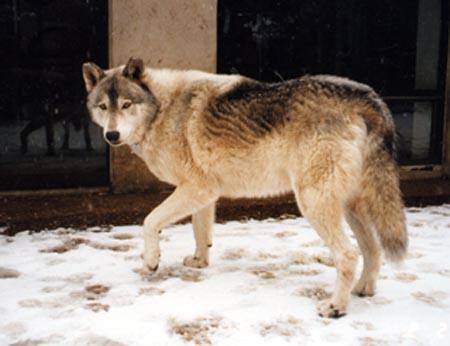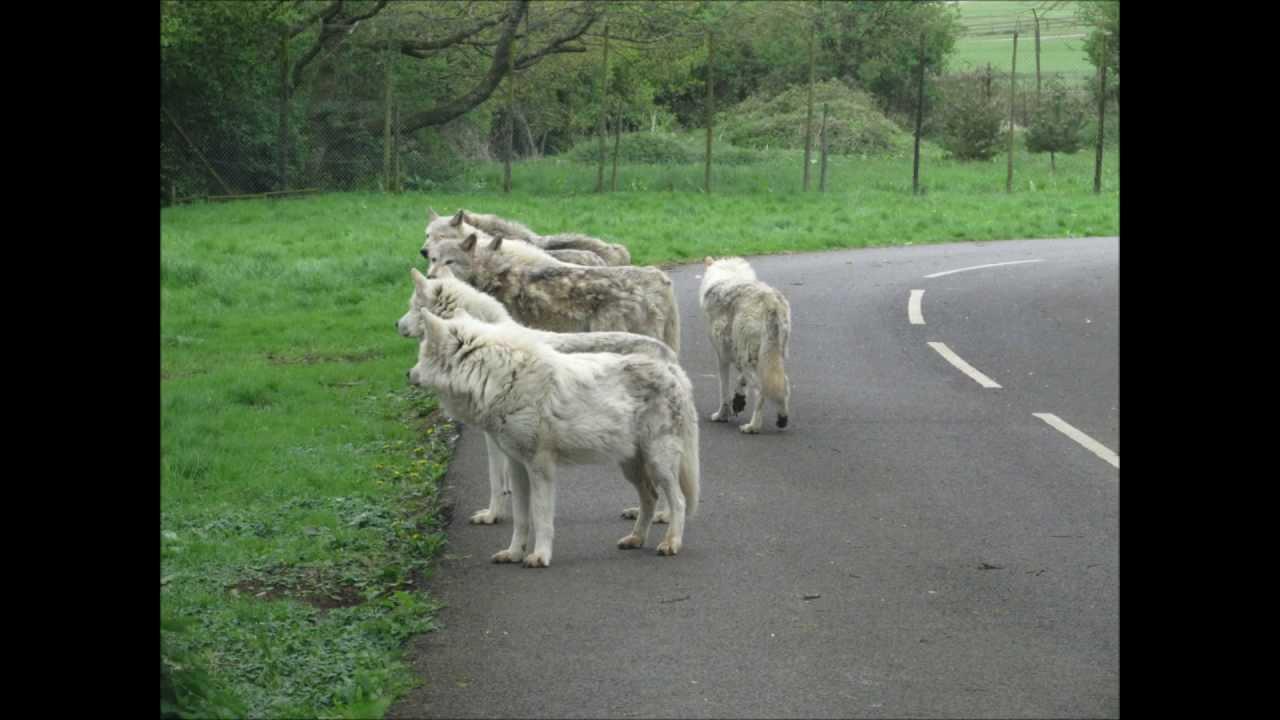The first image is the image on the left, the second image is the image on the right. Considering the images on both sides, is "Only the head of the animal is visible in the image on the left." valid? Answer yes or no. No. 